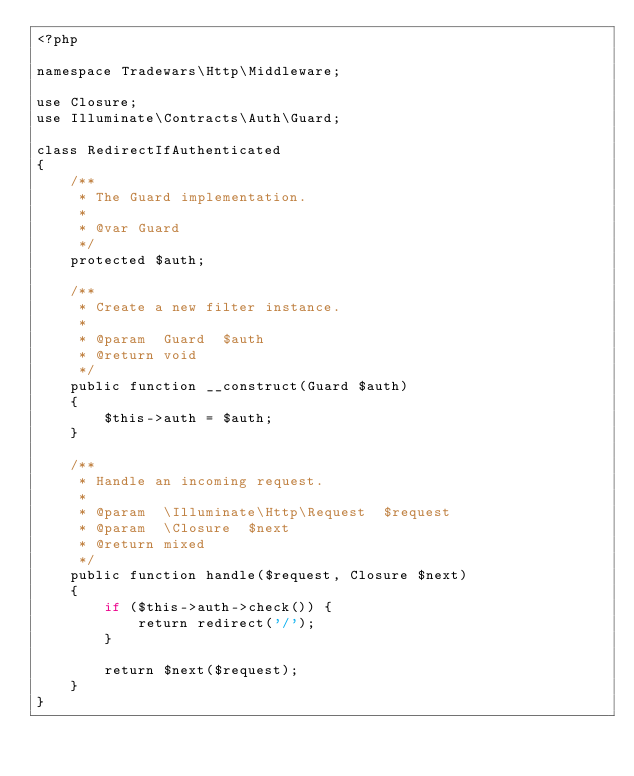Convert code to text. <code><loc_0><loc_0><loc_500><loc_500><_PHP_><?php

namespace Tradewars\Http\Middleware;

use Closure;
use Illuminate\Contracts\Auth\Guard;

class RedirectIfAuthenticated
{
    /**
     * The Guard implementation.
     *
     * @var Guard
     */
    protected $auth;

    /**
     * Create a new filter instance.
     *
     * @param  Guard  $auth
     * @return void
     */
    public function __construct(Guard $auth)
    {
        $this->auth = $auth;
    }

    /**
     * Handle an incoming request.
     *
     * @param  \Illuminate\Http\Request  $request
     * @param  \Closure  $next
     * @return mixed
     */
    public function handle($request, Closure $next)
    {
        if ($this->auth->check()) {
            return redirect('/');
        }

        return $next($request);
    }
}
</code> 